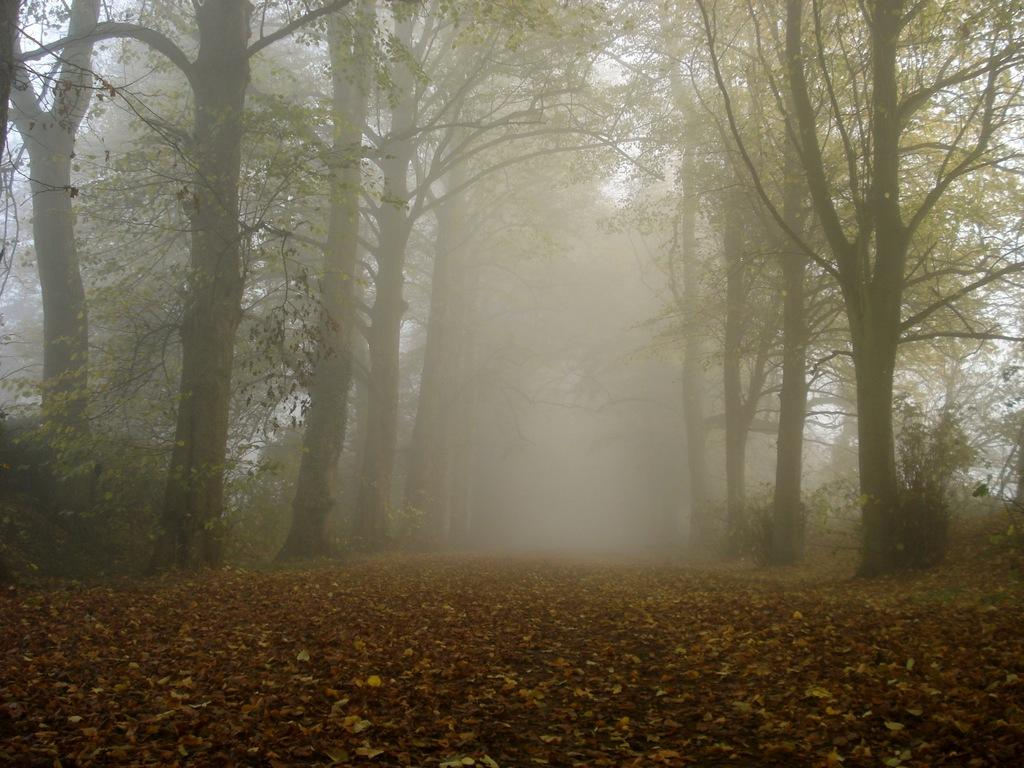What is present at the bottom of the image? There are leaves at the bottom of the image. What can be seen in the background of the image? There are trees in the background of the image. What is the weather condition in the middle of the image? There is fog in the middle of the image. What part of the natural environment is visible at the left top of the image? The sky is visible at the left top of the image. What type of wool is being spun by the pig in the image? There is no pig or wool present in the image. How many trees are visible in the image? The fact only mentions that there are trees in the background, so we cannot determine the exact number of trees visible in the image. 